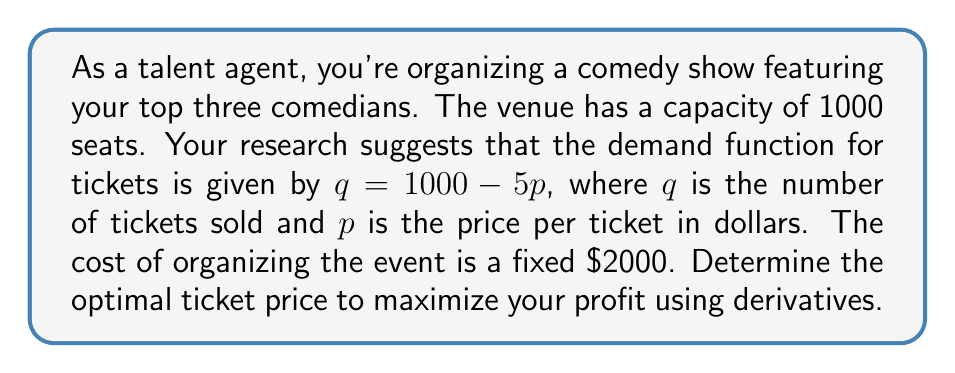Can you answer this question? Let's approach this step-by-step:

1) First, we need to set up the profit function. Profit is equal to revenue minus cost.

   Revenue = price × quantity = $p \times q = p(1000 - 5p)$
   Cost = $\$2000$ (fixed)

   Profit function: $\Pi(p) = p(1000 - 5p) - 2000$

2) Expand the profit function:
   $\Pi(p) = 1000p - 5p^2 - 2000$

3) To find the maximum profit, we need to find where the derivative of the profit function equals zero.

   $\frac{d\Pi}{dp} = 1000 - 10p$

4) Set the derivative equal to zero and solve for p:

   $1000 - 10p = 0$
   $-10p = -1000$
   $p = 100$

5) To confirm this is a maximum (not a minimum), check the second derivative:

   $\frac{d^2\Pi}{dp^2} = -10$

   Since this is negative, we confirm that $p = 100$ gives a maximum.

6) Calculate the maximum profit:

   $\Pi(100) = 100(1000 - 5(100)) - 2000$
              $= 100(500) - 2000$
              $= 50000 - 2000 = 48000$

Therefore, the optimal ticket price is $\$100$, which will result in a maximum profit of $\$48,000$.
Answer: The optimal ticket price is $\$100$. 